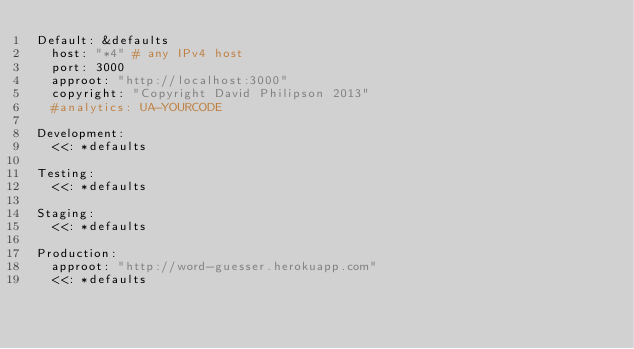Convert code to text. <code><loc_0><loc_0><loc_500><loc_500><_YAML_>Default: &defaults
  host: "*4" # any IPv4 host
  port: 3000
  approot: "http://localhost:3000"
  copyright: "Copyright David Philipson 2013"
  #analytics: UA-YOURCODE

Development:
  <<: *defaults

Testing:
  <<: *defaults

Staging:
  <<: *defaults

Production:
  approot: "http://word-guesser.herokuapp.com"
  <<: *defaults
</code> 